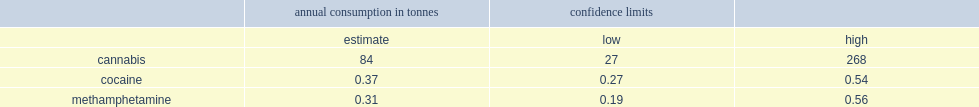What was the estimated number of annual consumption in tonnes(tonnes of dried product)? 84.0. What were the numbers of annual consumption in tonnes for cocaine and for methamphetamine(t)? 0.37 0.31. 